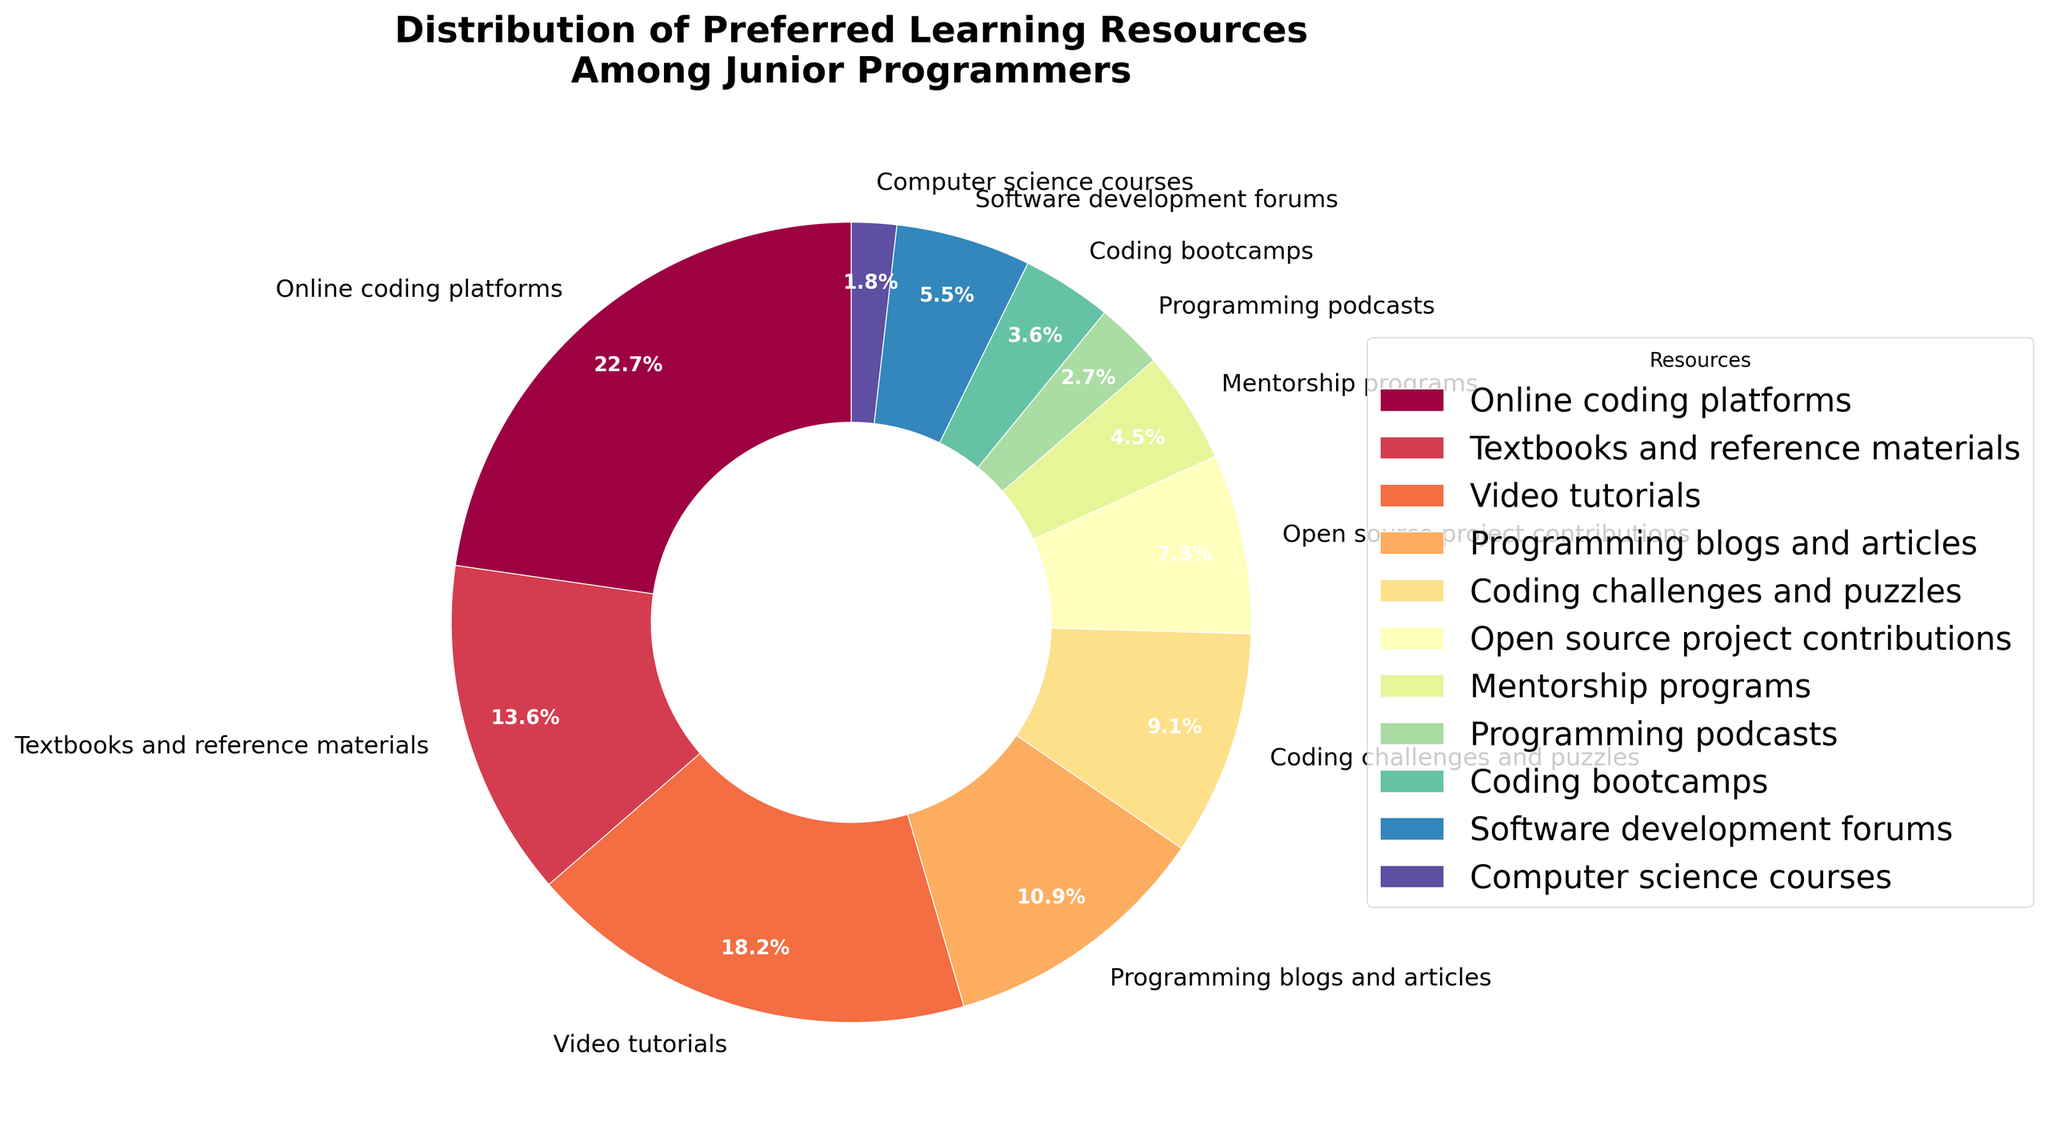What is the most preferred learning resource among junior programmers? According to the pie chart, the segment with the largest percentage represents the most preferred learning resource. The largest segment is for "Online coding platforms" with 25%.
Answer: Online coding platforms Which resource has the second-largest percentage? To determine the second-largest percentage, visually identify the second-largest segment in the pie chart. "Video tutorials" is the second-largest with 20%.
Answer: Video tutorials What is the combined percentage of "Programming blogs and articles" and "Coding challenges and puzzles"? Add the percentages for "Programming blogs and articles" (12%) and "Coding challenges and puzzles" (10%). 12% + 10% = 22%.
Answer: 22% How does the percentage of "Mentorship programs" compare to "Coding bootcamps"? Look at the percentages for both resources. "Mentorship programs" have 5%, while "Coding bootcamps" have 4%. Hence, "Mentorship programs" are 1% higher than "Coding bootcamps".
Answer: Mentorship programs are 1% higher What is the least preferred learning resource? Identify the segment with the smallest percentage in the pie chart. The smallest segment is "Computer science courses" with 2%.
Answer: Computer science courses How many resources have a percentage greater than 10%? Count the segments with percentages greater than 10%. They are "Online coding platforms" (25%), "Video tutorials" (20%), "Textbooks and reference materials" (15%), and "Programming blogs and articles" (12%). There are 4 segments.
Answer: 4 What is the combined percentage of resources that have single-digit percentages? Sum the percentages of resources with single-digit values: "Open source project contributions" (8%), "Software development forums" (6%), "Mentorship programs" (5%), "Programming podcasts" (3%), "Coding bootcamps" (4%), and "Computer science courses" (2%). 8% + 6% + 5% + 3% + 4% + 2% = 28%.
Answer: 28% Compare the segments for "Programming blogs and articles" and "Software development forums." Which is larger and by how much? "Programming blogs and articles" have a percentage of 12%, while "Software development forums" have 6%. The difference is 12% - 6% = 6%.
Answer: Programming blogs and articles are 6% larger What color represents "Coding bootcamps"? Look for the color associated with "Coding bootcamps" in the pie chart legend. The resource "Coding bootcamps" is marked in a segment colored with a particular shade (e.g., a specific section of the color spectrum).
Answer: Depends on the specific color How much more popular are "Online coding platforms" compared to "Programming podcasts"? Subtract the percentage of "Programming podcasts" (3%) from "Online coding platforms" (25%). 25% - 3% = 22%.
Answer: 22% 